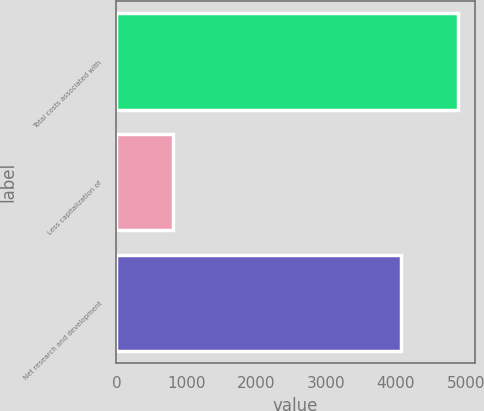Convert chart to OTSL. <chart><loc_0><loc_0><loc_500><loc_500><bar_chart><fcel>Total costs associated with<fcel>Less capitalization of<fcel>Net research and development<nl><fcel>4881<fcel>806<fcel>4075<nl></chart> 